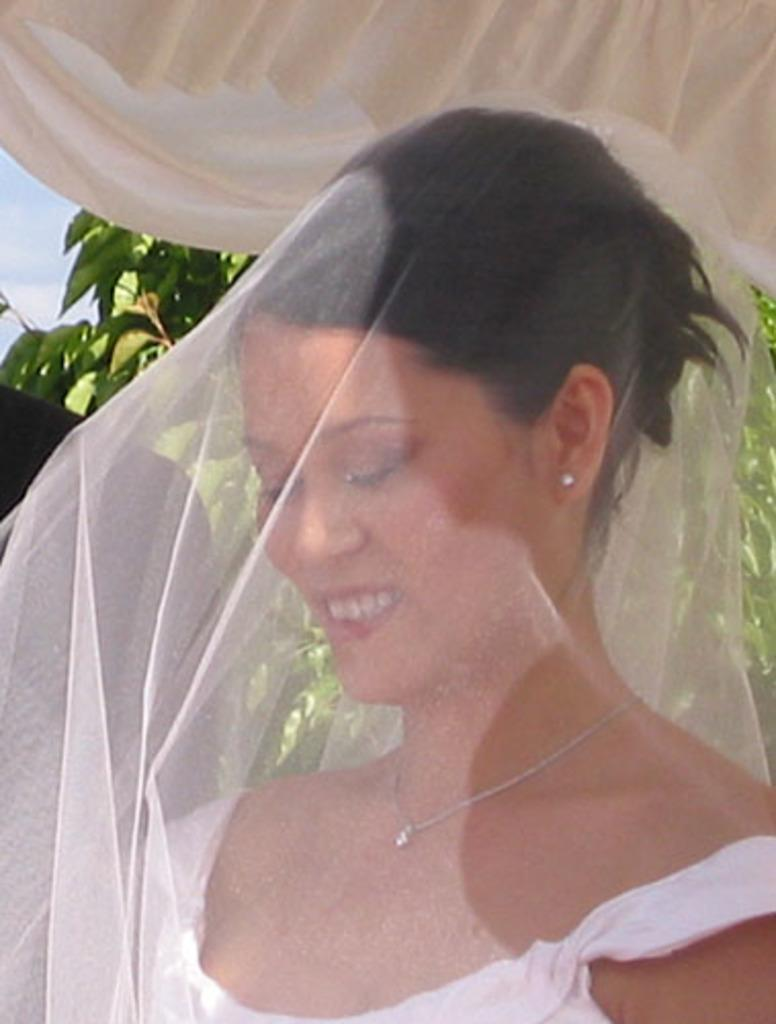Who is the main subject in the image? There is a lady in the image. What is covering the lady in the image? The lady is covered by a net. What is located at the top of the image? There is a cloth at the top of the image. What can be seen in the background of the image? There are branches with leaves in the background of the image. What part of the natural environment is visible in the image? The sky is visible in the image. How many snakes are slithering around the lady in the image? There are no snakes present in the image; the lady is covered by a net. What territory does the lady claim in the image? The image does not depict any territorial claims; it simply shows a lady covered by a net. 